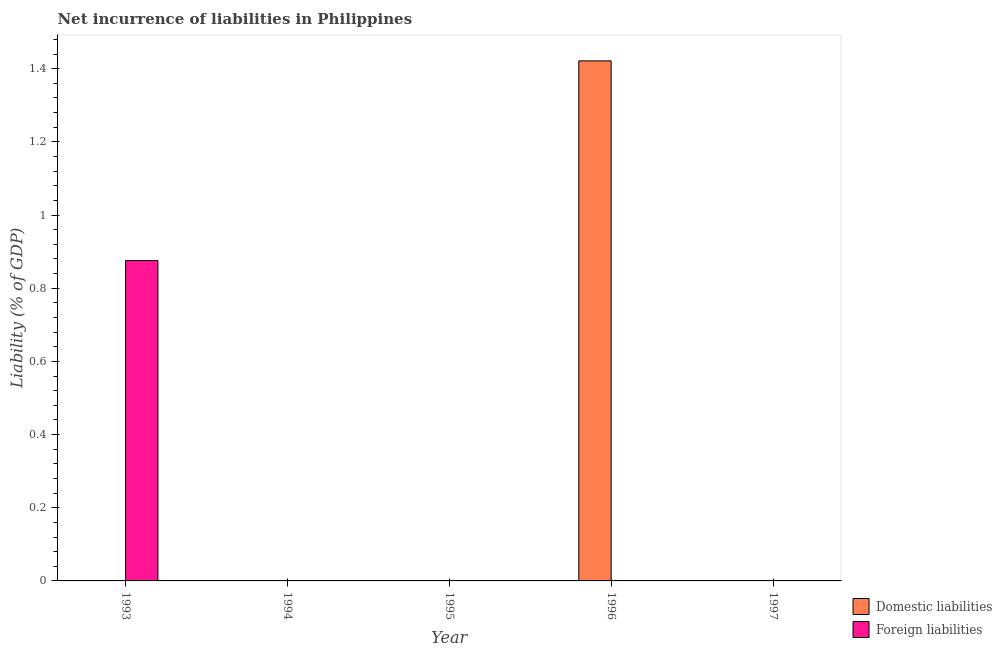How many different coloured bars are there?
Your answer should be compact. 2. Are the number of bars per tick equal to the number of legend labels?
Provide a succinct answer. No. How many bars are there on the 3rd tick from the left?
Offer a terse response. 0. How many bars are there on the 1st tick from the right?
Your answer should be compact. 0. In how many cases, is the number of bars for a given year not equal to the number of legend labels?
Provide a succinct answer. 5. What is the incurrence of foreign liabilities in 1996?
Your answer should be very brief. 0. Across all years, what is the maximum incurrence of foreign liabilities?
Keep it short and to the point. 0.88. Across all years, what is the minimum incurrence of domestic liabilities?
Provide a succinct answer. 0. In which year was the incurrence of foreign liabilities maximum?
Ensure brevity in your answer.  1993. What is the total incurrence of domestic liabilities in the graph?
Give a very brief answer. 1.42. What is the difference between the incurrence of domestic liabilities in 1997 and the incurrence of foreign liabilities in 1993?
Your answer should be very brief. 0. What is the average incurrence of foreign liabilities per year?
Make the answer very short. 0.18. In the year 1996, what is the difference between the incurrence of domestic liabilities and incurrence of foreign liabilities?
Offer a very short reply. 0. In how many years, is the incurrence of domestic liabilities greater than 1.08 %?
Your answer should be compact. 1. What is the difference between the highest and the lowest incurrence of foreign liabilities?
Ensure brevity in your answer.  0.88. How many years are there in the graph?
Provide a succinct answer. 5. What is the difference between two consecutive major ticks on the Y-axis?
Provide a succinct answer. 0.2. Does the graph contain grids?
Offer a very short reply. No. How many legend labels are there?
Ensure brevity in your answer.  2. What is the title of the graph?
Your answer should be very brief. Net incurrence of liabilities in Philippines. What is the label or title of the X-axis?
Offer a terse response. Year. What is the label or title of the Y-axis?
Ensure brevity in your answer.  Liability (% of GDP). What is the Liability (% of GDP) of Domestic liabilities in 1993?
Ensure brevity in your answer.  0. What is the Liability (% of GDP) in Foreign liabilities in 1993?
Your answer should be very brief. 0.88. What is the Liability (% of GDP) in Foreign liabilities in 1995?
Provide a short and direct response. 0. What is the Liability (% of GDP) of Domestic liabilities in 1996?
Make the answer very short. 1.42. What is the Liability (% of GDP) in Foreign liabilities in 1996?
Make the answer very short. 0. What is the Liability (% of GDP) in Domestic liabilities in 1997?
Ensure brevity in your answer.  0. Across all years, what is the maximum Liability (% of GDP) of Domestic liabilities?
Your answer should be compact. 1.42. Across all years, what is the maximum Liability (% of GDP) in Foreign liabilities?
Provide a short and direct response. 0.88. Across all years, what is the minimum Liability (% of GDP) of Domestic liabilities?
Offer a very short reply. 0. Across all years, what is the minimum Liability (% of GDP) of Foreign liabilities?
Provide a succinct answer. 0. What is the total Liability (% of GDP) of Domestic liabilities in the graph?
Make the answer very short. 1.42. What is the total Liability (% of GDP) in Foreign liabilities in the graph?
Offer a very short reply. 0.88. What is the average Liability (% of GDP) in Domestic liabilities per year?
Your answer should be very brief. 0.28. What is the average Liability (% of GDP) of Foreign liabilities per year?
Give a very brief answer. 0.18. What is the difference between the highest and the lowest Liability (% of GDP) in Domestic liabilities?
Give a very brief answer. 1.42. What is the difference between the highest and the lowest Liability (% of GDP) in Foreign liabilities?
Provide a short and direct response. 0.88. 